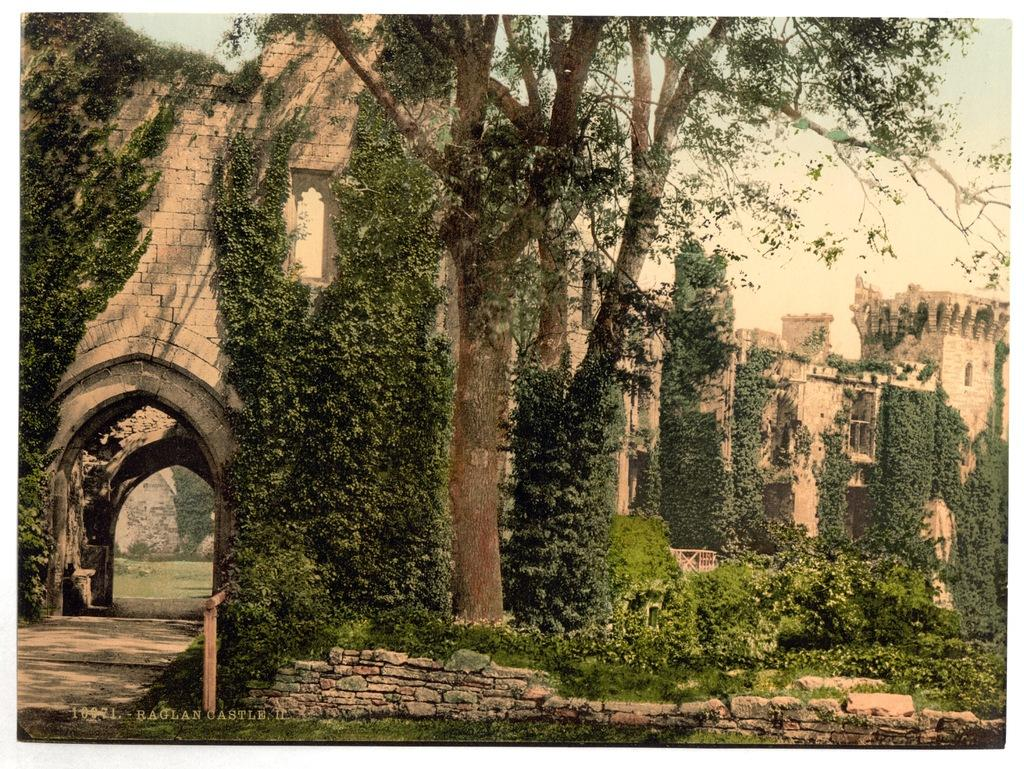What type of structure is visible in the image? There is a fort in the image. What type of vegetation can be seen in the image? There are trees and plants in the image. What is visible in the background of the image? The sky is visible in the background of the image. Can you tell me where the doctor is standing in the image? There is no doctor present in the image. What type of veil is covering the fort in the image? There is no veil present in the image; the fort is visible without any covering. 